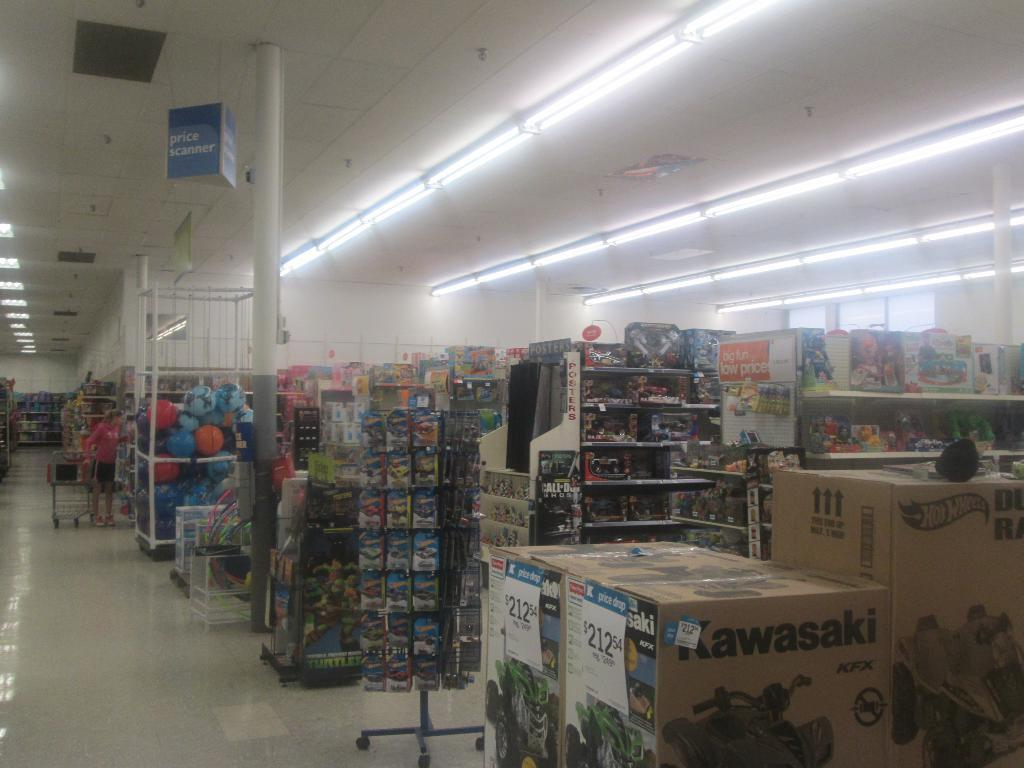<image>
Relay a brief, clear account of the picture shown. A view across rows of retail aisles at a large store, has Kawasaki scooters to Hot Wheels stuff 